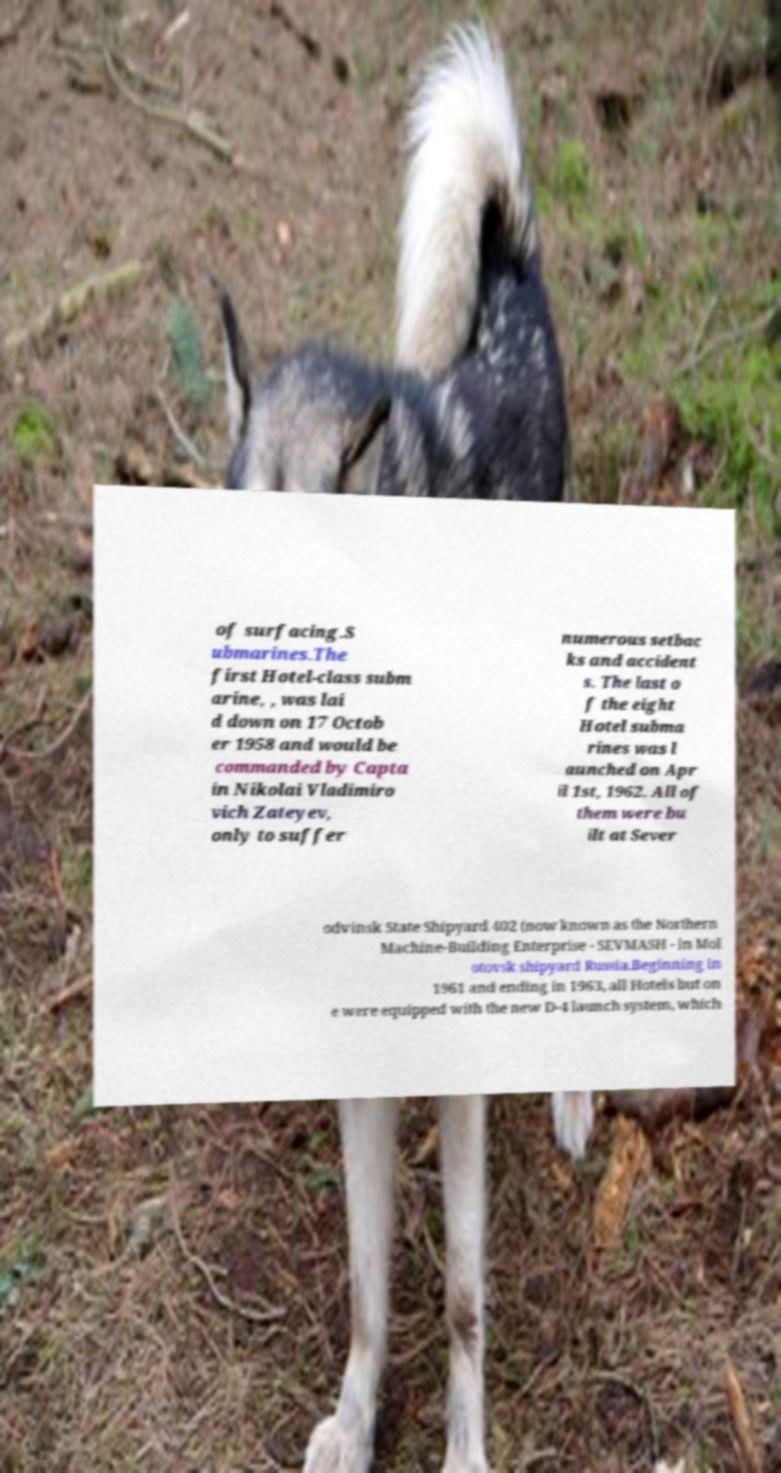I need the written content from this picture converted into text. Can you do that? of surfacing.S ubmarines.The first Hotel-class subm arine, , was lai d down on 17 Octob er 1958 and would be commanded by Capta in Nikolai Vladimiro vich Zateyev, only to suffer numerous setbac ks and accident s. The last o f the eight Hotel subma rines was l aunched on Apr il 1st, 1962. All of them were bu ilt at Sever odvinsk State Shipyard 402 (now known as the Northern Machine-Building Enterprise - SEVMASH - in Mol otovsk shipyard Russia.Beginning in 1961 and ending in 1963, all Hotels but on e were equipped with the new D-4 launch system, which 